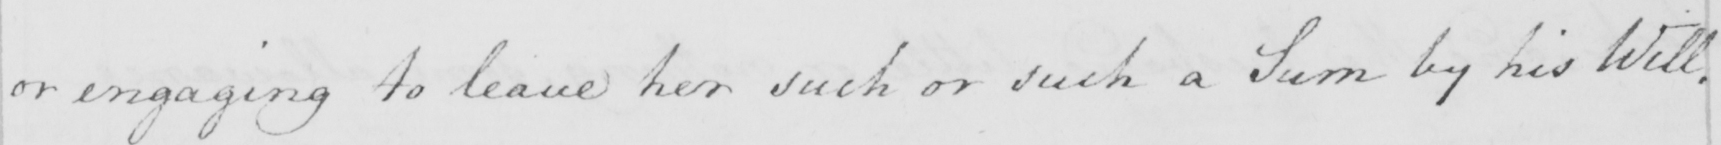Please transcribe the handwritten text in this image. or engaging to leave her such or such a Sum by his Will . 